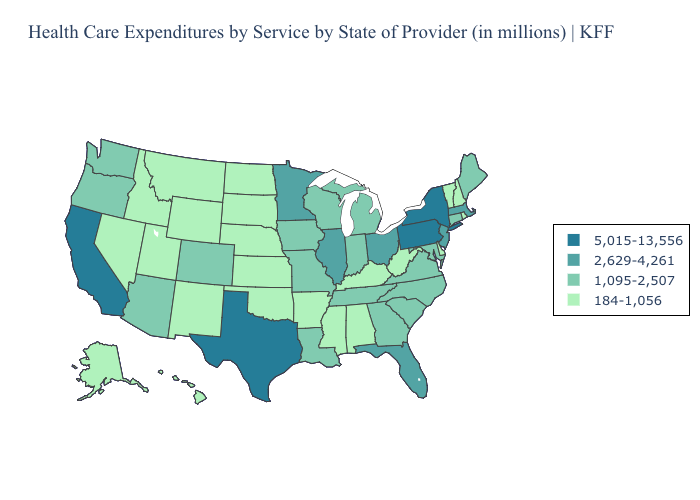Which states have the highest value in the USA?
Give a very brief answer. California, New York, Pennsylvania, Texas. Among the states that border Minnesota , which have the highest value?
Keep it brief. Iowa, Wisconsin. Name the states that have a value in the range 2,629-4,261?
Quick response, please. Florida, Illinois, Massachusetts, Minnesota, New Jersey, Ohio. Name the states that have a value in the range 5,015-13,556?
Concise answer only. California, New York, Pennsylvania, Texas. Does Pennsylvania have the lowest value in the Northeast?
Answer briefly. No. What is the value of Oregon?
Be succinct. 1,095-2,507. Does Kentucky have the lowest value in the South?
Quick response, please. Yes. Which states have the lowest value in the MidWest?
Concise answer only. Kansas, Nebraska, North Dakota, South Dakota. Among the states that border Kansas , which have the lowest value?
Quick response, please. Nebraska, Oklahoma. Which states have the highest value in the USA?
Quick response, please. California, New York, Pennsylvania, Texas. Among the states that border Iowa , which have the lowest value?
Give a very brief answer. Nebraska, South Dakota. Which states have the highest value in the USA?
Keep it brief. California, New York, Pennsylvania, Texas. Which states have the lowest value in the USA?
Concise answer only. Alabama, Alaska, Arkansas, Delaware, Hawaii, Idaho, Kansas, Kentucky, Mississippi, Montana, Nebraska, Nevada, New Hampshire, New Mexico, North Dakota, Oklahoma, Rhode Island, South Dakota, Utah, Vermont, West Virginia, Wyoming. Name the states that have a value in the range 2,629-4,261?
Quick response, please. Florida, Illinois, Massachusetts, Minnesota, New Jersey, Ohio. What is the highest value in the USA?
Concise answer only. 5,015-13,556. 